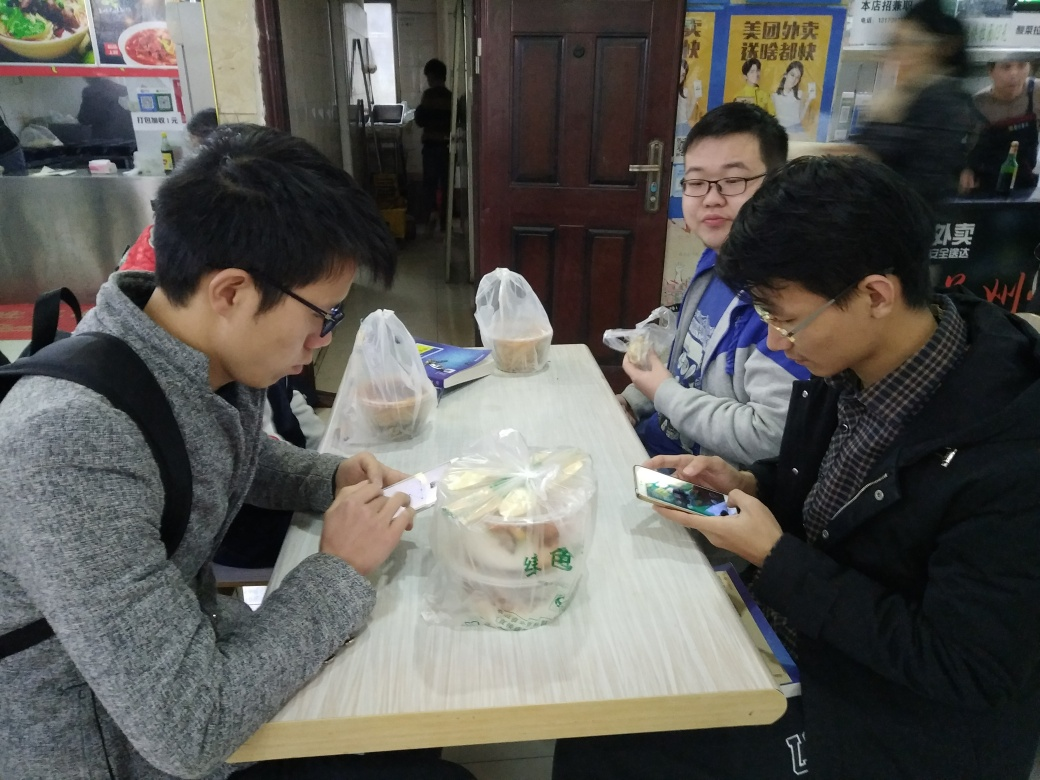What are the people in the image doing? The image captures a casual scene of three individuals at a dining table. The person on the left appears to be focused on opening a food package, likely a snack or meal. The person in the center is holding what seems to be a cup or small bowl, possibly enjoying a quick bite or a drink. Meanwhile, the individual on the right is engaged with their smartphone, which could indicate they are taking a break to catch up on messages or browse the internet. 